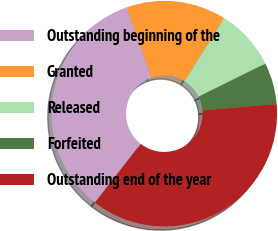<chart> <loc_0><loc_0><loc_500><loc_500><pie_chart><fcel>Outstanding beginning of the<fcel>Granted<fcel>Released<fcel>Forfeited<fcel>Outstanding end of the year<nl><fcel>34.07%<fcel>14.32%<fcel>8.76%<fcel>5.95%<fcel>36.89%<nl></chart> 